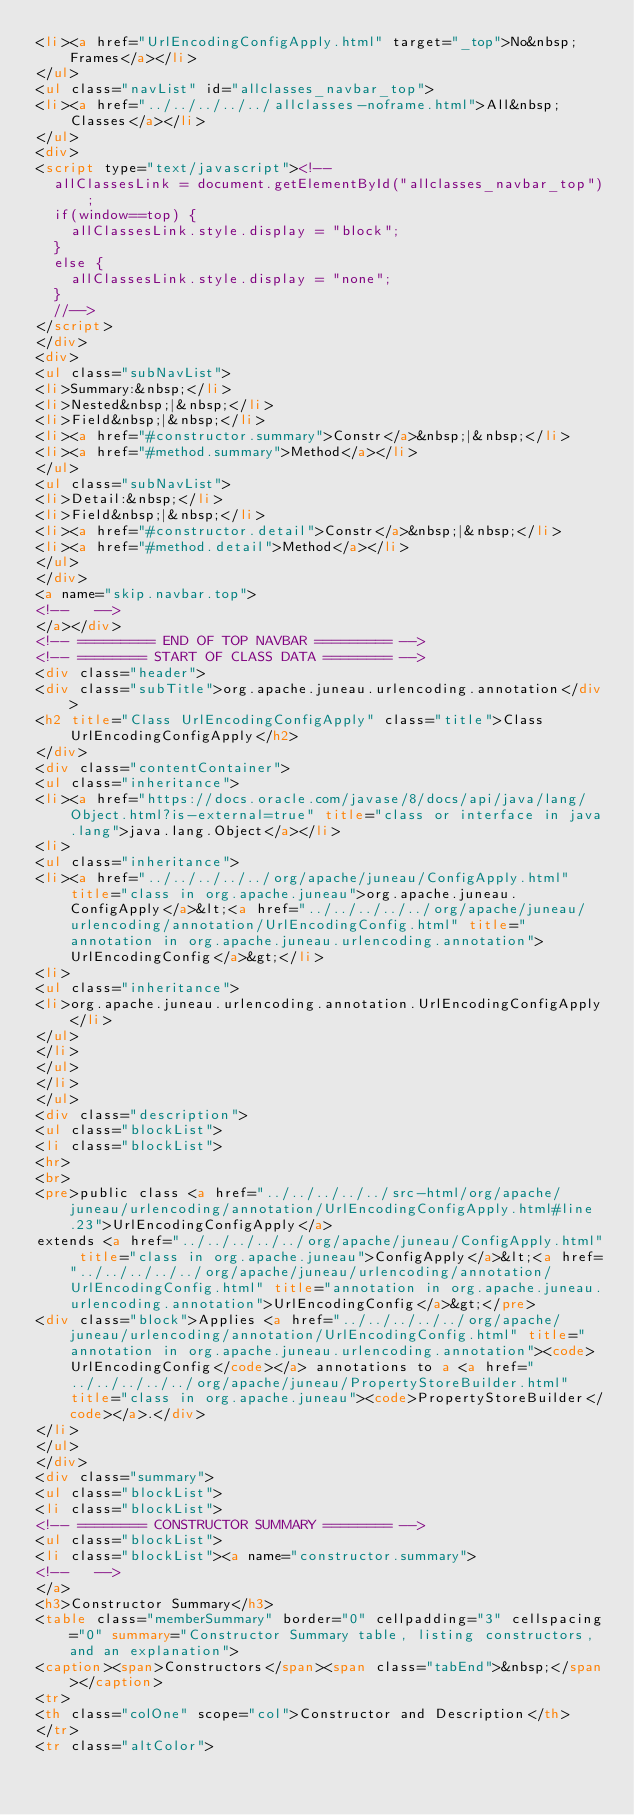Convert code to text. <code><loc_0><loc_0><loc_500><loc_500><_HTML_><li><a href="UrlEncodingConfigApply.html" target="_top">No&nbsp;Frames</a></li>
</ul>
<ul class="navList" id="allclasses_navbar_top">
<li><a href="../../../../../allclasses-noframe.html">All&nbsp;Classes</a></li>
</ul>
<div>
<script type="text/javascript"><!--
  allClassesLink = document.getElementById("allclasses_navbar_top");
  if(window==top) {
    allClassesLink.style.display = "block";
  }
  else {
    allClassesLink.style.display = "none";
  }
  //-->
</script>
</div>
<div>
<ul class="subNavList">
<li>Summary:&nbsp;</li>
<li>Nested&nbsp;|&nbsp;</li>
<li>Field&nbsp;|&nbsp;</li>
<li><a href="#constructor.summary">Constr</a>&nbsp;|&nbsp;</li>
<li><a href="#method.summary">Method</a></li>
</ul>
<ul class="subNavList">
<li>Detail:&nbsp;</li>
<li>Field&nbsp;|&nbsp;</li>
<li><a href="#constructor.detail">Constr</a>&nbsp;|&nbsp;</li>
<li><a href="#method.detail">Method</a></li>
</ul>
</div>
<a name="skip.navbar.top">
<!--   -->
</a></div>
<!-- ========= END OF TOP NAVBAR ========= -->
<!-- ======== START OF CLASS DATA ======== -->
<div class="header">
<div class="subTitle">org.apache.juneau.urlencoding.annotation</div>
<h2 title="Class UrlEncodingConfigApply" class="title">Class UrlEncodingConfigApply</h2>
</div>
<div class="contentContainer">
<ul class="inheritance">
<li><a href="https://docs.oracle.com/javase/8/docs/api/java/lang/Object.html?is-external=true" title="class or interface in java.lang">java.lang.Object</a></li>
<li>
<ul class="inheritance">
<li><a href="../../../../../org/apache/juneau/ConfigApply.html" title="class in org.apache.juneau">org.apache.juneau.ConfigApply</a>&lt;<a href="../../../../../org/apache/juneau/urlencoding/annotation/UrlEncodingConfig.html" title="annotation in org.apache.juneau.urlencoding.annotation">UrlEncodingConfig</a>&gt;</li>
<li>
<ul class="inheritance">
<li>org.apache.juneau.urlencoding.annotation.UrlEncodingConfigApply</li>
</ul>
</li>
</ul>
</li>
</ul>
<div class="description">
<ul class="blockList">
<li class="blockList">
<hr>
<br>
<pre>public class <a href="../../../../../src-html/org/apache/juneau/urlencoding/annotation/UrlEncodingConfigApply.html#line.23">UrlEncodingConfigApply</a>
extends <a href="../../../../../org/apache/juneau/ConfigApply.html" title="class in org.apache.juneau">ConfigApply</a>&lt;<a href="../../../../../org/apache/juneau/urlencoding/annotation/UrlEncodingConfig.html" title="annotation in org.apache.juneau.urlencoding.annotation">UrlEncodingConfig</a>&gt;</pre>
<div class="block">Applies <a href="../../../../../org/apache/juneau/urlencoding/annotation/UrlEncodingConfig.html" title="annotation in org.apache.juneau.urlencoding.annotation"><code>UrlEncodingConfig</code></a> annotations to a <a href="../../../../../org/apache/juneau/PropertyStoreBuilder.html" title="class in org.apache.juneau"><code>PropertyStoreBuilder</code></a>.</div>
</li>
</ul>
</div>
<div class="summary">
<ul class="blockList">
<li class="blockList">
<!-- ======== CONSTRUCTOR SUMMARY ======== -->
<ul class="blockList">
<li class="blockList"><a name="constructor.summary">
<!--   -->
</a>
<h3>Constructor Summary</h3>
<table class="memberSummary" border="0" cellpadding="3" cellspacing="0" summary="Constructor Summary table, listing constructors, and an explanation">
<caption><span>Constructors</span><span class="tabEnd">&nbsp;</span></caption>
<tr>
<th class="colOne" scope="col">Constructor and Description</th>
</tr>
<tr class="altColor"></code> 